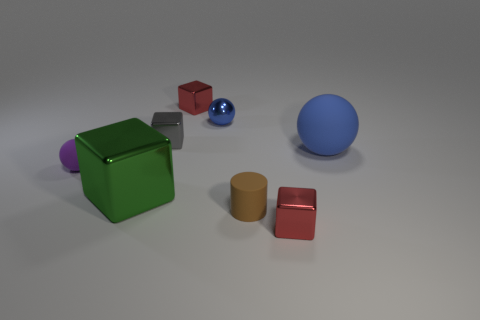How many balls have the same material as the small cylinder?
Your answer should be very brief. 2. Are there fewer rubber cylinders to the left of the brown matte object than small red rubber spheres?
Your answer should be very brief. No. What size is the blue sphere that is behind the blue matte sphere that is to the right of the small brown cylinder?
Offer a terse response. Small. Is the color of the large metallic object the same as the metal cube to the right of the tiny blue thing?
Offer a very short reply. No. What is the material of the purple sphere that is the same size as the brown rubber cylinder?
Your answer should be compact. Rubber. Is the number of tiny blue metal objects left of the large metallic cube less than the number of large blue rubber objects that are in front of the big blue thing?
Your answer should be very brief. No. The big object that is to the left of the big object on the right side of the small brown cylinder is what shape?
Provide a short and direct response. Cube. Are there any blue metal objects?
Provide a succinct answer. Yes. What is the color of the small rubber object in front of the green metal cube?
Provide a succinct answer. Brown. There is a large object that is the same color as the tiny metal ball; what is its material?
Provide a short and direct response. Rubber. 